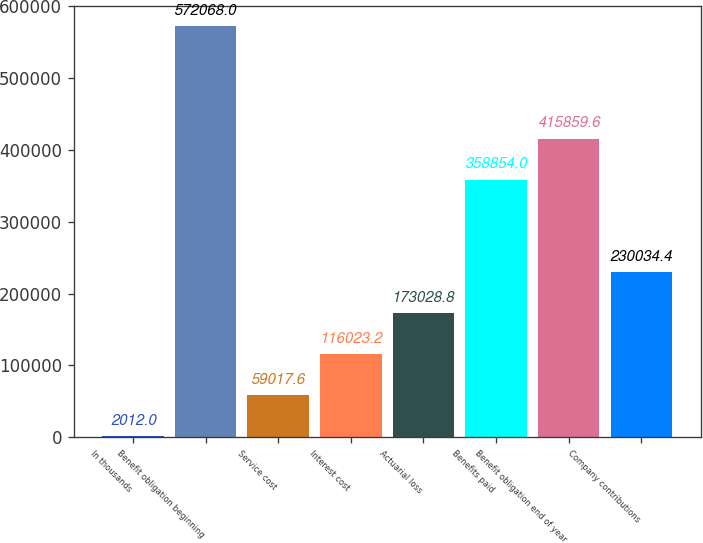Convert chart to OTSL. <chart><loc_0><loc_0><loc_500><loc_500><bar_chart><fcel>In thousands<fcel>Benefit obligation beginning<fcel>Service cost<fcel>Interest cost<fcel>Actuarial loss<fcel>Benefits paid<fcel>Benefit obligation end of year<fcel>Company contributions<nl><fcel>2012<fcel>572068<fcel>59017.6<fcel>116023<fcel>173029<fcel>358854<fcel>415860<fcel>230034<nl></chart> 